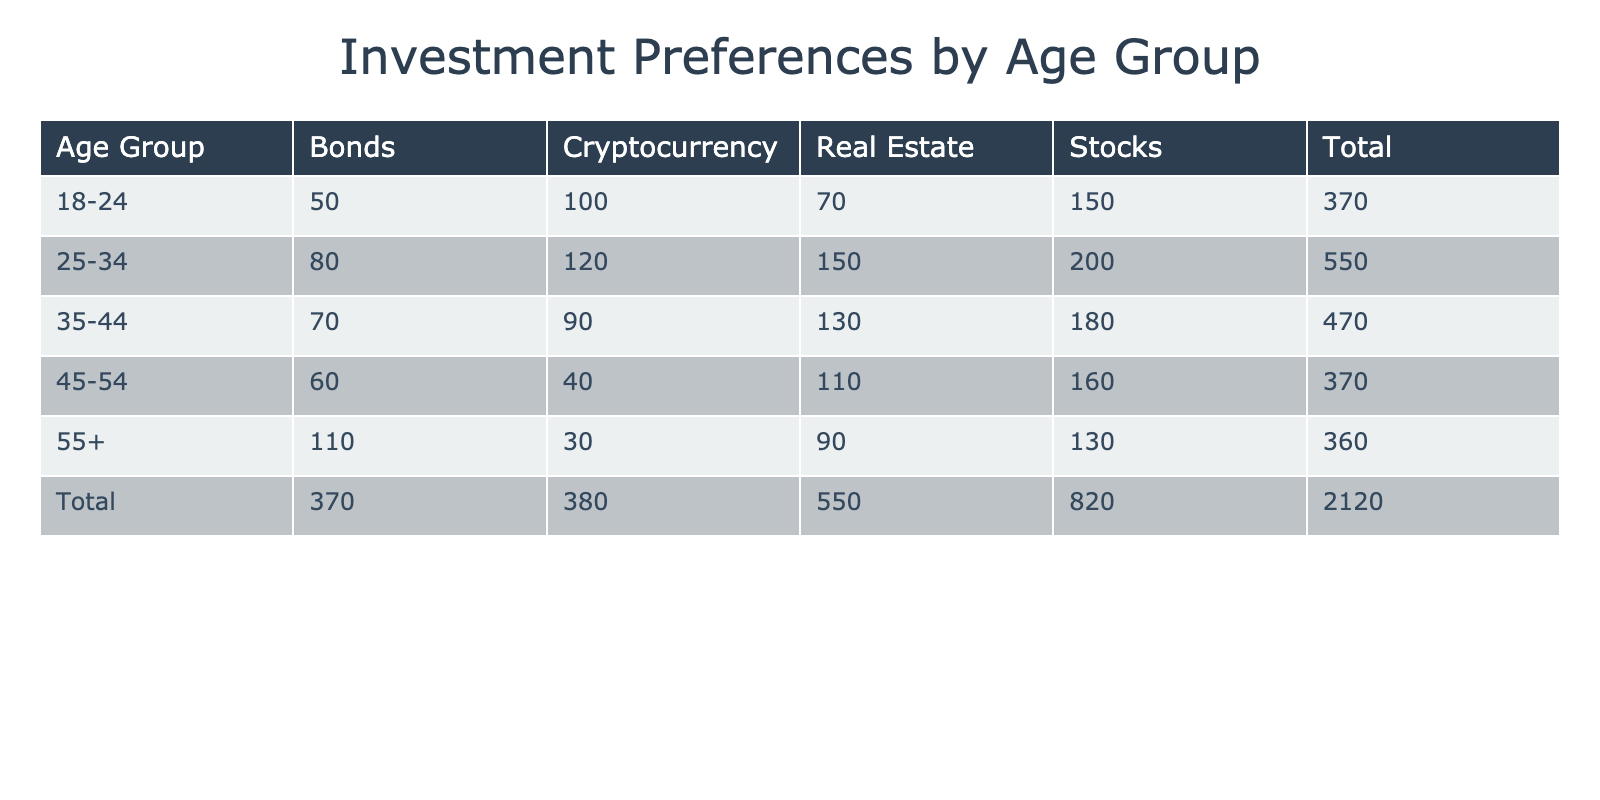What is the total frequency of investment preferences for the age group 25-34? To find the total frequency for the age group 25-34, we sum the frequency values in that row: Stocks (200) + Bonds (80) + Real Estate (150) + Cryptocurrency (120) = 550.
Answer: 550 How many people prefer Bonds across all age groups? To find the total number of people who prefer Bonds, we look at the column for Bonds and sum the values: 50 (age 18-24) + 80 (age 25-34) + 70 (age 35-44) + 60 (age 45-54) + 110 (age 55+) = 370.
Answer: 370 What percentage of the 35-44 age group prefers Cryptocurrency? The total frequency for the age group 35-44 is 180 (Stocks) + 70 (Bonds) + 130 (Real Estate) + 90 (Cryptocurrency) = 470. The frequency for Cryptocurrency in this group is 90. The percentage is calculated as (90 / 470) * 100 = 19.15%.
Answer: 19.15% Is it true that the preference for Real Estate decreases with age? To verify this, we can compare the frequencies for Real Estate across the age groups: 70 (18-24), 150 (25-34), 130 (35-44), 110 (45-54), and 90 (55+). The values show an initial increase from age 18-24 to 25-34, but then a decrease in the older groups (35-44 to 55+). Thus, we cannot say that it decreases consistently with age as the trend varies.
Answer: No What is the difference in the total frequency of Stocks and Real Estate for the age group 45-54? First, we find the frequencies for Stocks and Real Estate in the age group 45-54: Stocks = 160 and Real Estate = 110. The difference is calculated as 160 - 110 = 50.
Answer: 50 What is the average frequency of investment preferences for people aged 55 and above? The total frequency for the age group 55+ is: Stocks (130) + Bonds (110) + Real Estate (90) + Cryptocurrency (30) = 360. There are 4 investment preferences in this age group, so the average is 360 / 4 = 90.
Answer: 90 Which investment preference has the highest total frequency across all age groups? We need to sum the frequencies for each investment preference: Stocks = 200 + 180 + 160 + 130 = 670, Bonds = 50 + 80 + 70 + 60 + 110 = 370, Real Estate = 70 + 150 + 130 + 110 + 90 = 550, Cryptocurrency = 100 + 120 + 90 + 40 + 30 = 380. Stocks have the highest frequency at 670.
Answer: Stocks 